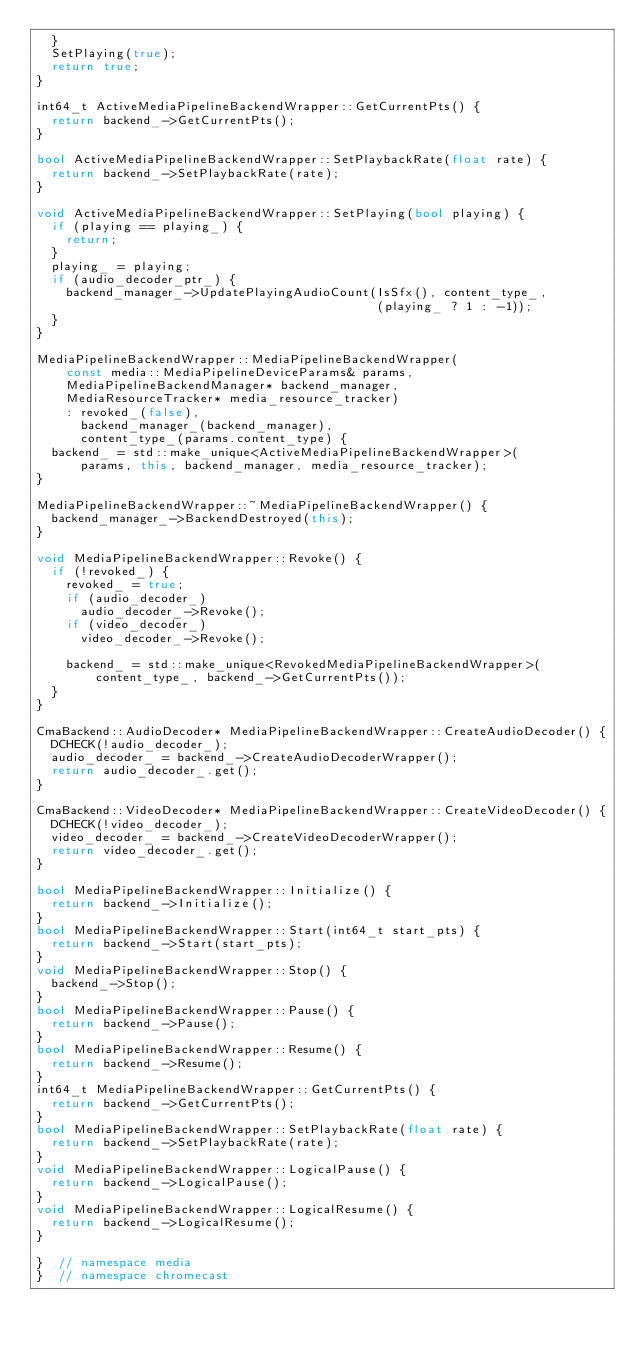<code> <loc_0><loc_0><loc_500><loc_500><_C++_>  }
  SetPlaying(true);
  return true;
}

int64_t ActiveMediaPipelineBackendWrapper::GetCurrentPts() {
  return backend_->GetCurrentPts();
}

bool ActiveMediaPipelineBackendWrapper::SetPlaybackRate(float rate) {
  return backend_->SetPlaybackRate(rate);
}

void ActiveMediaPipelineBackendWrapper::SetPlaying(bool playing) {
  if (playing == playing_) {
    return;
  }
  playing_ = playing;
  if (audio_decoder_ptr_) {
    backend_manager_->UpdatePlayingAudioCount(IsSfx(), content_type_,
                                              (playing_ ? 1 : -1));
  }
}

MediaPipelineBackendWrapper::MediaPipelineBackendWrapper(
    const media::MediaPipelineDeviceParams& params,
    MediaPipelineBackendManager* backend_manager,
    MediaResourceTracker* media_resource_tracker)
    : revoked_(false),
      backend_manager_(backend_manager),
      content_type_(params.content_type) {
  backend_ = std::make_unique<ActiveMediaPipelineBackendWrapper>(
      params, this, backend_manager, media_resource_tracker);
}

MediaPipelineBackendWrapper::~MediaPipelineBackendWrapper() {
  backend_manager_->BackendDestroyed(this);
}

void MediaPipelineBackendWrapper::Revoke() {
  if (!revoked_) {
    revoked_ = true;
    if (audio_decoder_)
      audio_decoder_->Revoke();
    if (video_decoder_)
      video_decoder_->Revoke();

    backend_ = std::make_unique<RevokedMediaPipelineBackendWrapper>(
        content_type_, backend_->GetCurrentPts());
  }
}

CmaBackend::AudioDecoder* MediaPipelineBackendWrapper::CreateAudioDecoder() {
  DCHECK(!audio_decoder_);
  audio_decoder_ = backend_->CreateAudioDecoderWrapper();
  return audio_decoder_.get();
}

CmaBackend::VideoDecoder* MediaPipelineBackendWrapper::CreateVideoDecoder() {
  DCHECK(!video_decoder_);
  video_decoder_ = backend_->CreateVideoDecoderWrapper();
  return video_decoder_.get();
}

bool MediaPipelineBackendWrapper::Initialize() {
  return backend_->Initialize();
}
bool MediaPipelineBackendWrapper::Start(int64_t start_pts) {
  return backend_->Start(start_pts);
}
void MediaPipelineBackendWrapper::Stop() {
  backend_->Stop();
}
bool MediaPipelineBackendWrapper::Pause() {
  return backend_->Pause();
}
bool MediaPipelineBackendWrapper::Resume() {
  return backend_->Resume();
}
int64_t MediaPipelineBackendWrapper::GetCurrentPts() {
  return backend_->GetCurrentPts();
}
bool MediaPipelineBackendWrapper::SetPlaybackRate(float rate) {
  return backend_->SetPlaybackRate(rate);
}
void MediaPipelineBackendWrapper::LogicalPause() {
  return backend_->LogicalPause();
}
void MediaPipelineBackendWrapper::LogicalResume() {
  return backend_->LogicalResume();
}

}  // namespace media
}  // namespace chromecast
</code> 